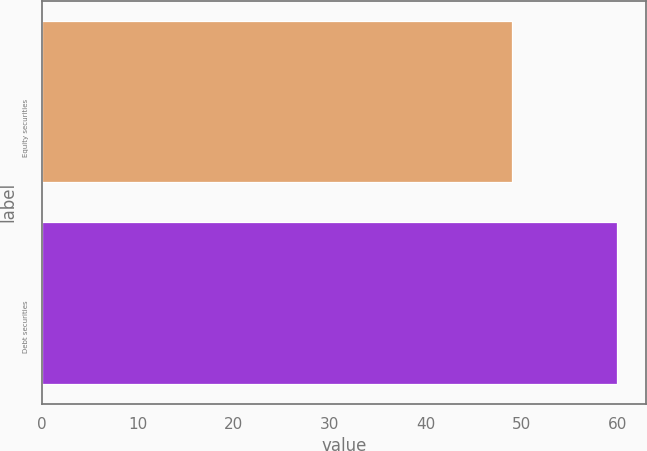Convert chart to OTSL. <chart><loc_0><loc_0><loc_500><loc_500><bar_chart><fcel>Equity securities<fcel>Debt securities<nl><fcel>49<fcel>60<nl></chart> 